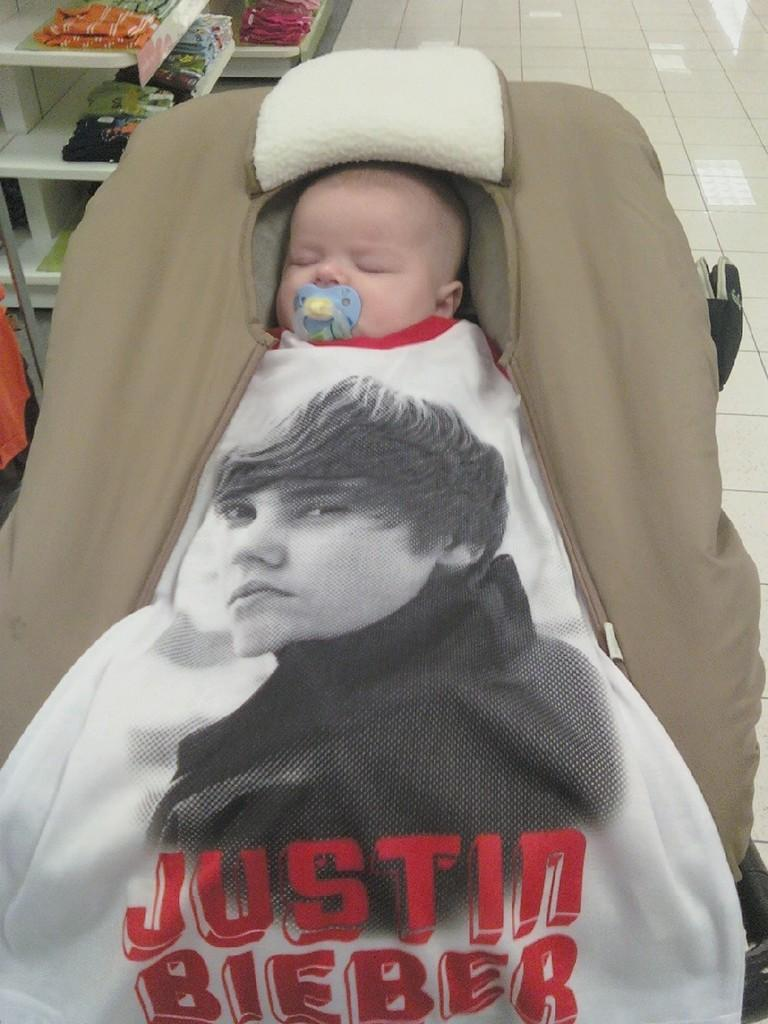What is the main subject in the foreground of the image? There is a baby in the foreground of the image. How is the baby dressed or covered in the image? The baby is covered with cloth. What can be seen in the background of the image? There are clothes on racks in the background of the image. What type of bird can be seen flying in the image? There is no bird present in the image. Is the baby sitting on a chair in the image? There is no chair visible in the image. 